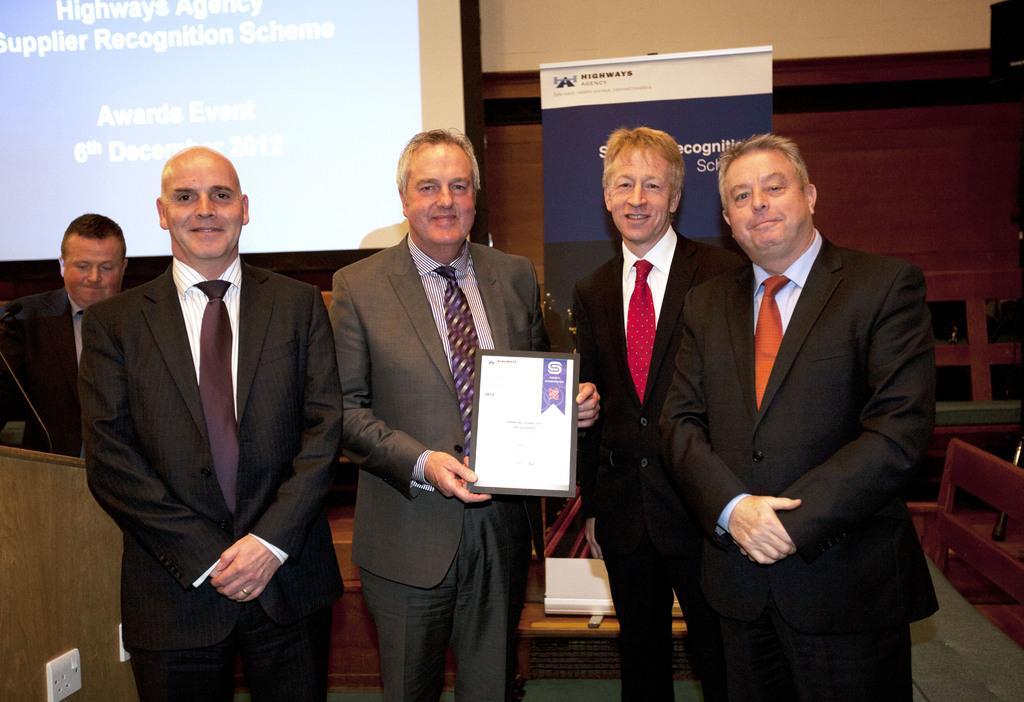Please provide a concise description of this image. In the center of the image we can see some people are standing and wearing suits and smiling and a man is holding a certificate. In the background of the image we can see a screen, board, wall. On the right side of the image we can see the benches. At the bottom of the image we can see the floor, table. On the table we can see a book. On the left side of the image we can see a man is standing in-front of podium. On the podium we can see a mic with stand and socket boards. 